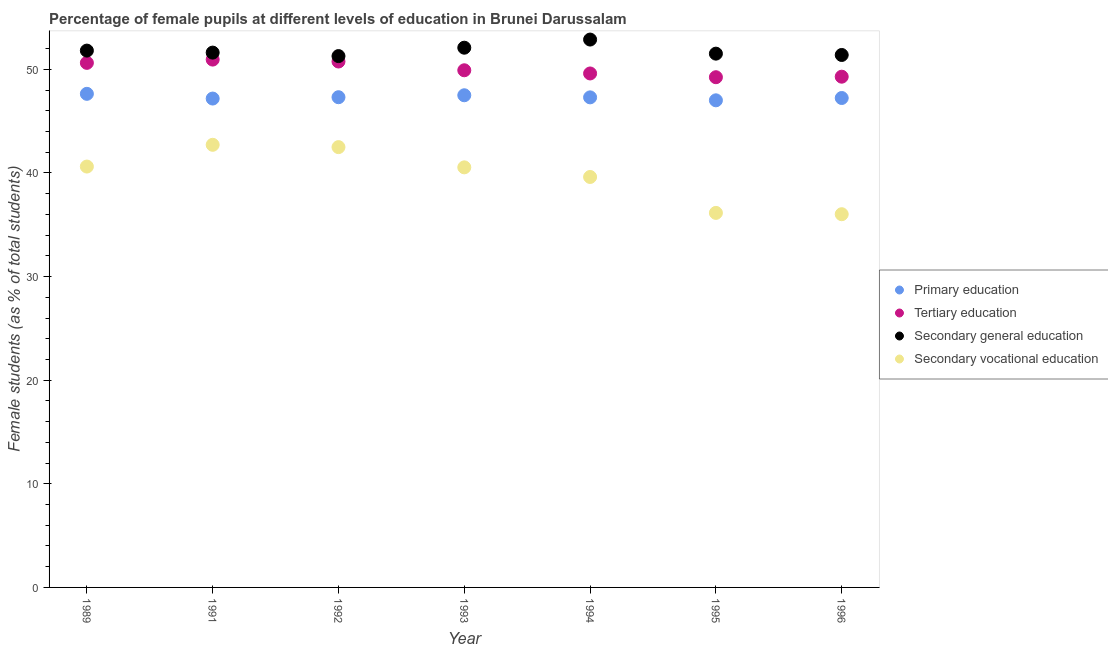What is the percentage of female students in tertiary education in 1993?
Ensure brevity in your answer.  49.91. Across all years, what is the maximum percentage of female students in primary education?
Your answer should be compact. 47.63. Across all years, what is the minimum percentage of female students in tertiary education?
Your answer should be compact. 49.24. In which year was the percentage of female students in secondary vocational education minimum?
Keep it short and to the point. 1996. What is the total percentage of female students in primary education in the graph?
Offer a terse response. 331.15. What is the difference between the percentage of female students in secondary vocational education in 1993 and that in 1996?
Provide a short and direct response. 4.52. What is the difference between the percentage of female students in secondary vocational education in 1993 and the percentage of female students in primary education in 1991?
Ensure brevity in your answer.  -6.64. What is the average percentage of female students in tertiary education per year?
Provide a short and direct response. 50.05. In the year 1989, what is the difference between the percentage of female students in primary education and percentage of female students in secondary education?
Provide a short and direct response. -4.17. In how many years, is the percentage of female students in secondary vocational education greater than 38 %?
Your answer should be compact. 5. What is the ratio of the percentage of female students in secondary education in 1991 to that in 1994?
Keep it short and to the point. 0.98. Is the percentage of female students in secondary education in 1989 less than that in 1992?
Your answer should be very brief. No. What is the difference between the highest and the second highest percentage of female students in secondary vocational education?
Offer a very short reply. 0.22. What is the difference between the highest and the lowest percentage of female students in secondary education?
Ensure brevity in your answer.  1.59. Is the sum of the percentage of female students in secondary vocational education in 1989 and 1991 greater than the maximum percentage of female students in primary education across all years?
Your answer should be compact. Yes. Is it the case that in every year, the sum of the percentage of female students in tertiary education and percentage of female students in secondary education is greater than the sum of percentage of female students in primary education and percentage of female students in secondary vocational education?
Your answer should be very brief. Yes. Is the percentage of female students in secondary education strictly greater than the percentage of female students in tertiary education over the years?
Give a very brief answer. Yes. Where does the legend appear in the graph?
Give a very brief answer. Center right. How are the legend labels stacked?
Offer a terse response. Vertical. What is the title of the graph?
Make the answer very short. Percentage of female pupils at different levels of education in Brunei Darussalam. What is the label or title of the Y-axis?
Offer a very short reply. Female students (as % of total students). What is the Female students (as % of total students) of Primary education in 1989?
Provide a succinct answer. 47.63. What is the Female students (as % of total students) of Tertiary education in 1989?
Ensure brevity in your answer.  50.62. What is the Female students (as % of total students) of Secondary general education in 1989?
Give a very brief answer. 51.81. What is the Female students (as % of total students) of Secondary vocational education in 1989?
Your answer should be compact. 40.62. What is the Female students (as % of total students) of Primary education in 1991?
Your response must be concise. 47.18. What is the Female students (as % of total students) in Tertiary education in 1991?
Your response must be concise. 50.94. What is the Female students (as % of total students) in Secondary general education in 1991?
Your response must be concise. 51.61. What is the Female students (as % of total students) of Secondary vocational education in 1991?
Your response must be concise. 42.72. What is the Female students (as % of total students) of Primary education in 1992?
Keep it short and to the point. 47.31. What is the Female students (as % of total students) of Tertiary education in 1992?
Give a very brief answer. 50.75. What is the Female students (as % of total students) in Secondary general education in 1992?
Provide a succinct answer. 51.28. What is the Female students (as % of total students) of Secondary vocational education in 1992?
Ensure brevity in your answer.  42.49. What is the Female students (as % of total students) in Primary education in 1993?
Your response must be concise. 47.5. What is the Female students (as % of total students) of Tertiary education in 1993?
Provide a succinct answer. 49.91. What is the Female students (as % of total students) of Secondary general education in 1993?
Your answer should be compact. 52.09. What is the Female students (as % of total students) in Secondary vocational education in 1993?
Provide a succinct answer. 40.54. What is the Female students (as % of total students) of Primary education in 1994?
Your answer should be compact. 47.29. What is the Female students (as % of total students) of Tertiary education in 1994?
Offer a very short reply. 49.6. What is the Female students (as % of total students) of Secondary general education in 1994?
Keep it short and to the point. 52.87. What is the Female students (as % of total students) of Secondary vocational education in 1994?
Keep it short and to the point. 39.61. What is the Female students (as % of total students) of Primary education in 1995?
Offer a very short reply. 47.01. What is the Female students (as % of total students) in Tertiary education in 1995?
Give a very brief answer. 49.24. What is the Female students (as % of total students) in Secondary general education in 1995?
Your answer should be compact. 51.51. What is the Female students (as % of total students) in Secondary vocational education in 1995?
Provide a short and direct response. 36.14. What is the Female students (as % of total students) in Primary education in 1996?
Provide a short and direct response. 47.23. What is the Female students (as % of total students) of Tertiary education in 1996?
Your answer should be compact. 49.29. What is the Female students (as % of total students) in Secondary general education in 1996?
Offer a terse response. 51.38. What is the Female students (as % of total students) of Secondary vocational education in 1996?
Keep it short and to the point. 36.02. Across all years, what is the maximum Female students (as % of total students) of Primary education?
Make the answer very short. 47.63. Across all years, what is the maximum Female students (as % of total students) of Tertiary education?
Your answer should be compact. 50.94. Across all years, what is the maximum Female students (as % of total students) in Secondary general education?
Offer a terse response. 52.87. Across all years, what is the maximum Female students (as % of total students) in Secondary vocational education?
Offer a very short reply. 42.72. Across all years, what is the minimum Female students (as % of total students) of Primary education?
Your answer should be compact. 47.01. Across all years, what is the minimum Female students (as % of total students) in Tertiary education?
Your answer should be compact. 49.24. Across all years, what is the minimum Female students (as % of total students) in Secondary general education?
Ensure brevity in your answer.  51.28. Across all years, what is the minimum Female students (as % of total students) in Secondary vocational education?
Offer a terse response. 36.02. What is the total Female students (as % of total students) in Primary education in the graph?
Offer a very short reply. 331.15. What is the total Female students (as % of total students) of Tertiary education in the graph?
Your answer should be very brief. 350.35. What is the total Female students (as % of total students) of Secondary general education in the graph?
Your answer should be compact. 362.55. What is the total Female students (as % of total students) of Secondary vocational education in the graph?
Your answer should be very brief. 278.13. What is the difference between the Female students (as % of total students) in Primary education in 1989 and that in 1991?
Offer a very short reply. 0.46. What is the difference between the Female students (as % of total students) in Tertiary education in 1989 and that in 1991?
Give a very brief answer. -0.32. What is the difference between the Female students (as % of total students) of Secondary general education in 1989 and that in 1991?
Provide a short and direct response. 0.19. What is the difference between the Female students (as % of total students) of Secondary vocational education in 1989 and that in 1991?
Give a very brief answer. -2.1. What is the difference between the Female students (as % of total students) in Primary education in 1989 and that in 1992?
Keep it short and to the point. 0.33. What is the difference between the Female students (as % of total students) of Tertiary education in 1989 and that in 1992?
Provide a short and direct response. -0.13. What is the difference between the Female students (as % of total students) in Secondary general education in 1989 and that in 1992?
Make the answer very short. 0.53. What is the difference between the Female students (as % of total students) of Secondary vocational education in 1989 and that in 1992?
Keep it short and to the point. -1.88. What is the difference between the Female students (as % of total students) of Primary education in 1989 and that in 1993?
Provide a short and direct response. 0.14. What is the difference between the Female students (as % of total students) of Tertiary education in 1989 and that in 1993?
Provide a short and direct response. 0.71. What is the difference between the Female students (as % of total students) of Secondary general education in 1989 and that in 1993?
Make the answer very short. -0.28. What is the difference between the Female students (as % of total students) of Secondary vocational education in 1989 and that in 1993?
Your response must be concise. 0.08. What is the difference between the Female students (as % of total students) in Primary education in 1989 and that in 1994?
Your response must be concise. 0.34. What is the difference between the Female students (as % of total students) of Tertiary education in 1989 and that in 1994?
Offer a terse response. 1.02. What is the difference between the Female students (as % of total students) of Secondary general education in 1989 and that in 1994?
Ensure brevity in your answer.  -1.07. What is the difference between the Female students (as % of total students) in Secondary vocational education in 1989 and that in 1994?
Offer a terse response. 1.01. What is the difference between the Female students (as % of total students) in Primary education in 1989 and that in 1995?
Your response must be concise. 0.63. What is the difference between the Female students (as % of total students) in Tertiary education in 1989 and that in 1995?
Make the answer very short. 1.38. What is the difference between the Female students (as % of total students) of Secondary general education in 1989 and that in 1995?
Provide a short and direct response. 0.29. What is the difference between the Female students (as % of total students) in Secondary vocational education in 1989 and that in 1995?
Your response must be concise. 4.47. What is the difference between the Female students (as % of total students) in Primary education in 1989 and that in 1996?
Your response must be concise. 0.4. What is the difference between the Female students (as % of total students) in Tertiary education in 1989 and that in 1996?
Ensure brevity in your answer.  1.33. What is the difference between the Female students (as % of total students) in Secondary general education in 1989 and that in 1996?
Your answer should be very brief. 0.42. What is the difference between the Female students (as % of total students) in Secondary vocational education in 1989 and that in 1996?
Offer a terse response. 4.6. What is the difference between the Female students (as % of total students) of Primary education in 1991 and that in 1992?
Make the answer very short. -0.13. What is the difference between the Female students (as % of total students) of Tertiary education in 1991 and that in 1992?
Offer a terse response. 0.19. What is the difference between the Female students (as % of total students) of Secondary general education in 1991 and that in 1992?
Ensure brevity in your answer.  0.34. What is the difference between the Female students (as % of total students) of Secondary vocational education in 1991 and that in 1992?
Your answer should be compact. 0.22. What is the difference between the Female students (as % of total students) of Primary education in 1991 and that in 1993?
Offer a very short reply. -0.32. What is the difference between the Female students (as % of total students) of Tertiary education in 1991 and that in 1993?
Ensure brevity in your answer.  1.03. What is the difference between the Female students (as % of total students) in Secondary general education in 1991 and that in 1993?
Ensure brevity in your answer.  -0.47. What is the difference between the Female students (as % of total students) in Secondary vocational education in 1991 and that in 1993?
Your answer should be compact. 2.18. What is the difference between the Female students (as % of total students) of Primary education in 1991 and that in 1994?
Give a very brief answer. -0.12. What is the difference between the Female students (as % of total students) in Tertiary education in 1991 and that in 1994?
Keep it short and to the point. 1.34. What is the difference between the Female students (as % of total students) in Secondary general education in 1991 and that in 1994?
Your answer should be very brief. -1.26. What is the difference between the Female students (as % of total students) of Secondary vocational education in 1991 and that in 1994?
Your response must be concise. 3.1. What is the difference between the Female students (as % of total students) of Primary education in 1991 and that in 1995?
Keep it short and to the point. 0.17. What is the difference between the Female students (as % of total students) of Tertiary education in 1991 and that in 1995?
Your response must be concise. 1.7. What is the difference between the Female students (as % of total students) in Secondary general education in 1991 and that in 1995?
Provide a short and direct response. 0.1. What is the difference between the Female students (as % of total students) of Secondary vocational education in 1991 and that in 1995?
Provide a short and direct response. 6.57. What is the difference between the Female students (as % of total students) of Primary education in 1991 and that in 1996?
Provide a succinct answer. -0.05. What is the difference between the Female students (as % of total students) of Tertiary education in 1991 and that in 1996?
Your response must be concise. 1.65. What is the difference between the Female students (as % of total students) in Secondary general education in 1991 and that in 1996?
Offer a terse response. 0.23. What is the difference between the Female students (as % of total students) in Secondary vocational education in 1991 and that in 1996?
Make the answer very short. 6.7. What is the difference between the Female students (as % of total students) in Primary education in 1992 and that in 1993?
Your answer should be compact. -0.19. What is the difference between the Female students (as % of total students) of Tertiary education in 1992 and that in 1993?
Provide a short and direct response. 0.84. What is the difference between the Female students (as % of total students) in Secondary general education in 1992 and that in 1993?
Give a very brief answer. -0.81. What is the difference between the Female students (as % of total students) in Secondary vocational education in 1992 and that in 1993?
Keep it short and to the point. 1.95. What is the difference between the Female students (as % of total students) in Primary education in 1992 and that in 1994?
Offer a very short reply. 0.01. What is the difference between the Female students (as % of total students) in Tertiary education in 1992 and that in 1994?
Give a very brief answer. 1.15. What is the difference between the Female students (as % of total students) of Secondary general education in 1992 and that in 1994?
Your answer should be very brief. -1.59. What is the difference between the Female students (as % of total students) in Secondary vocational education in 1992 and that in 1994?
Offer a very short reply. 2.88. What is the difference between the Female students (as % of total students) of Primary education in 1992 and that in 1995?
Provide a short and direct response. 0.3. What is the difference between the Female students (as % of total students) in Tertiary education in 1992 and that in 1995?
Offer a terse response. 1.51. What is the difference between the Female students (as % of total students) of Secondary general education in 1992 and that in 1995?
Provide a succinct answer. -0.23. What is the difference between the Female students (as % of total students) in Secondary vocational education in 1992 and that in 1995?
Provide a short and direct response. 6.35. What is the difference between the Female students (as % of total students) in Primary education in 1992 and that in 1996?
Offer a terse response. 0.08. What is the difference between the Female students (as % of total students) in Tertiary education in 1992 and that in 1996?
Provide a succinct answer. 1.46. What is the difference between the Female students (as % of total students) in Secondary general education in 1992 and that in 1996?
Offer a terse response. -0.11. What is the difference between the Female students (as % of total students) of Secondary vocational education in 1992 and that in 1996?
Your response must be concise. 6.48. What is the difference between the Female students (as % of total students) in Primary education in 1993 and that in 1994?
Your answer should be very brief. 0.2. What is the difference between the Female students (as % of total students) in Tertiary education in 1993 and that in 1994?
Provide a short and direct response. 0.31. What is the difference between the Female students (as % of total students) of Secondary general education in 1993 and that in 1994?
Provide a succinct answer. -0.79. What is the difference between the Female students (as % of total students) of Secondary vocational education in 1993 and that in 1994?
Make the answer very short. 0.93. What is the difference between the Female students (as % of total students) of Primary education in 1993 and that in 1995?
Keep it short and to the point. 0.49. What is the difference between the Female students (as % of total students) in Tertiary education in 1993 and that in 1995?
Your answer should be very brief. 0.67. What is the difference between the Female students (as % of total students) in Secondary general education in 1993 and that in 1995?
Offer a very short reply. 0.57. What is the difference between the Female students (as % of total students) in Secondary vocational education in 1993 and that in 1995?
Give a very brief answer. 4.39. What is the difference between the Female students (as % of total students) in Primary education in 1993 and that in 1996?
Provide a short and direct response. 0.26. What is the difference between the Female students (as % of total students) in Tertiary education in 1993 and that in 1996?
Provide a succinct answer. 0.62. What is the difference between the Female students (as % of total students) of Secondary general education in 1993 and that in 1996?
Offer a very short reply. 0.7. What is the difference between the Female students (as % of total students) of Secondary vocational education in 1993 and that in 1996?
Offer a very short reply. 4.52. What is the difference between the Female students (as % of total students) in Primary education in 1994 and that in 1995?
Your answer should be very brief. 0.29. What is the difference between the Female students (as % of total students) in Tertiary education in 1994 and that in 1995?
Your answer should be very brief. 0.36. What is the difference between the Female students (as % of total students) in Secondary general education in 1994 and that in 1995?
Keep it short and to the point. 1.36. What is the difference between the Female students (as % of total students) of Secondary vocational education in 1994 and that in 1995?
Your answer should be compact. 3.47. What is the difference between the Female students (as % of total students) of Primary education in 1994 and that in 1996?
Your response must be concise. 0.06. What is the difference between the Female students (as % of total students) in Tertiary education in 1994 and that in 1996?
Your response must be concise. 0.31. What is the difference between the Female students (as % of total students) of Secondary general education in 1994 and that in 1996?
Offer a very short reply. 1.49. What is the difference between the Female students (as % of total students) of Secondary vocational education in 1994 and that in 1996?
Offer a very short reply. 3.59. What is the difference between the Female students (as % of total students) in Primary education in 1995 and that in 1996?
Your answer should be very brief. -0.22. What is the difference between the Female students (as % of total students) of Tertiary education in 1995 and that in 1996?
Your answer should be very brief. -0.05. What is the difference between the Female students (as % of total students) of Secondary general education in 1995 and that in 1996?
Your answer should be compact. 0.13. What is the difference between the Female students (as % of total students) in Secondary vocational education in 1995 and that in 1996?
Offer a terse response. 0.13. What is the difference between the Female students (as % of total students) of Primary education in 1989 and the Female students (as % of total students) of Tertiary education in 1991?
Your answer should be very brief. -3.3. What is the difference between the Female students (as % of total students) in Primary education in 1989 and the Female students (as % of total students) in Secondary general education in 1991?
Your answer should be compact. -3.98. What is the difference between the Female students (as % of total students) of Primary education in 1989 and the Female students (as % of total students) of Secondary vocational education in 1991?
Give a very brief answer. 4.92. What is the difference between the Female students (as % of total students) in Tertiary education in 1989 and the Female students (as % of total students) in Secondary general education in 1991?
Keep it short and to the point. -0.99. What is the difference between the Female students (as % of total students) in Tertiary education in 1989 and the Female students (as % of total students) in Secondary vocational education in 1991?
Give a very brief answer. 7.91. What is the difference between the Female students (as % of total students) of Secondary general education in 1989 and the Female students (as % of total students) of Secondary vocational education in 1991?
Keep it short and to the point. 9.09. What is the difference between the Female students (as % of total students) in Primary education in 1989 and the Female students (as % of total students) in Tertiary education in 1992?
Provide a short and direct response. -3.12. What is the difference between the Female students (as % of total students) in Primary education in 1989 and the Female students (as % of total students) in Secondary general education in 1992?
Give a very brief answer. -3.64. What is the difference between the Female students (as % of total students) in Primary education in 1989 and the Female students (as % of total students) in Secondary vocational education in 1992?
Offer a very short reply. 5.14. What is the difference between the Female students (as % of total students) in Tertiary education in 1989 and the Female students (as % of total students) in Secondary general education in 1992?
Your answer should be very brief. -0.66. What is the difference between the Female students (as % of total students) of Tertiary education in 1989 and the Female students (as % of total students) of Secondary vocational education in 1992?
Provide a short and direct response. 8.13. What is the difference between the Female students (as % of total students) of Secondary general education in 1989 and the Female students (as % of total students) of Secondary vocational education in 1992?
Provide a short and direct response. 9.31. What is the difference between the Female students (as % of total students) of Primary education in 1989 and the Female students (as % of total students) of Tertiary education in 1993?
Your answer should be very brief. -2.27. What is the difference between the Female students (as % of total students) in Primary education in 1989 and the Female students (as % of total students) in Secondary general education in 1993?
Offer a terse response. -4.45. What is the difference between the Female students (as % of total students) of Primary education in 1989 and the Female students (as % of total students) of Secondary vocational education in 1993?
Your response must be concise. 7.1. What is the difference between the Female students (as % of total students) in Tertiary education in 1989 and the Female students (as % of total students) in Secondary general education in 1993?
Make the answer very short. -1.46. What is the difference between the Female students (as % of total students) of Tertiary education in 1989 and the Female students (as % of total students) of Secondary vocational education in 1993?
Your answer should be very brief. 10.08. What is the difference between the Female students (as % of total students) of Secondary general education in 1989 and the Female students (as % of total students) of Secondary vocational education in 1993?
Provide a short and direct response. 11.27. What is the difference between the Female students (as % of total students) of Primary education in 1989 and the Female students (as % of total students) of Tertiary education in 1994?
Make the answer very short. -1.97. What is the difference between the Female students (as % of total students) in Primary education in 1989 and the Female students (as % of total students) in Secondary general education in 1994?
Your answer should be very brief. -5.24. What is the difference between the Female students (as % of total students) in Primary education in 1989 and the Female students (as % of total students) in Secondary vocational education in 1994?
Provide a short and direct response. 8.02. What is the difference between the Female students (as % of total students) in Tertiary education in 1989 and the Female students (as % of total students) in Secondary general education in 1994?
Ensure brevity in your answer.  -2.25. What is the difference between the Female students (as % of total students) in Tertiary education in 1989 and the Female students (as % of total students) in Secondary vocational education in 1994?
Give a very brief answer. 11.01. What is the difference between the Female students (as % of total students) in Secondary general education in 1989 and the Female students (as % of total students) in Secondary vocational education in 1994?
Keep it short and to the point. 12.2. What is the difference between the Female students (as % of total students) of Primary education in 1989 and the Female students (as % of total students) of Tertiary education in 1995?
Make the answer very short. -1.6. What is the difference between the Female students (as % of total students) in Primary education in 1989 and the Female students (as % of total students) in Secondary general education in 1995?
Offer a terse response. -3.88. What is the difference between the Female students (as % of total students) of Primary education in 1989 and the Female students (as % of total students) of Secondary vocational education in 1995?
Make the answer very short. 11.49. What is the difference between the Female students (as % of total students) in Tertiary education in 1989 and the Female students (as % of total students) in Secondary general education in 1995?
Provide a short and direct response. -0.89. What is the difference between the Female students (as % of total students) in Tertiary education in 1989 and the Female students (as % of total students) in Secondary vocational education in 1995?
Provide a succinct answer. 14.48. What is the difference between the Female students (as % of total students) in Secondary general education in 1989 and the Female students (as % of total students) in Secondary vocational education in 1995?
Your answer should be compact. 15.66. What is the difference between the Female students (as % of total students) of Primary education in 1989 and the Female students (as % of total students) of Tertiary education in 1996?
Ensure brevity in your answer.  -1.65. What is the difference between the Female students (as % of total students) of Primary education in 1989 and the Female students (as % of total students) of Secondary general education in 1996?
Make the answer very short. -3.75. What is the difference between the Female students (as % of total students) in Primary education in 1989 and the Female students (as % of total students) in Secondary vocational education in 1996?
Provide a short and direct response. 11.62. What is the difference between the Female students (as % of total students) in Tertiary education in 1989 and the Female students (as % of total students) in Secondary general education in 1996?
Give a very brief answer. -0.76. What is the difference between the Female students (as % of total students) of Tertiary education in 1989 and the Female students (as % of total students) of Secondary vocational education in 1996?
Provide a short and direct response. 14.61. What is the difference between the Female students (as % of total students) of Secondary general education in 1989 and the Female students (as % of total students) of Secondary vocational education in 1996?
Offer a very short reply. 15.79. What is the difference between the Female students (as % of total students) of Primary education in 1991 and the Female students (as % of total students) of Tertiary education in 1992?
Ensure brevity in your answer.  -3.57. What is the difference between the Female students (as % of total students) of Primary education in 1991 and the Female students (as % of total students) of Secondary general education in 1992?
Provide a short and direct response. -4.1. What is the difference between the Female students (as % of total students) in Primary education in 1991 and the Female students (as % of total students) in Secondary vocational education in 1992?
Your answer should be compact. 4.69. What is the difference between the Female students (as % of total students) of Tertiary education in 1991 and the Female students (as % of total students) of Secondary general education in 1992?
Make the answer very short. -0.34. What is the difference between the Female students (as % of total students) in Tertiary education in 1991 and the Female students (as % of total students) in Secondary vocational education in 1992?
Keep it short and to the point. 8.45. What is the difference between the Female students (as % of total students) of Secondary general education in 1991 and the Female students (as % of total students) of Secondary vocational education in 1992?
Keep it short and to the point. 9.12. What is the difference between the Female students (as % of total students) in Primary education in 1991 and the Female students (as % of total students) in Tertiary education in 1993?
Keep it short and to the point. -2.73. What is the difference between the Female students (as % of total students) in Primary education in 1991 and the Female students (as % of total students) in Secondary general education in 1993?
Your answer should be compact. -4.91. What is the difference between the Female students (as % of total students) in Primary education in 1991 and the Female students (as % of total students) in Secondary vocational education in 1993?
Your response must be concise. 6.64. What is the difference between the Female students (as % of total students) in Tertiary education in 1991 and the Female students (as % of total students) in Secondary general education in 1993?
Give a very brief answer. -1.15. What is the difference between the Female students (as % of total students) in Tertiary education in 1991 and the Female students (as % of total students) in Secondary vocational education in 1993?
Your answer should be very brief. 10.4. What is the difference between the Female students (as % of total students) in Secondary general education in 1991 and the Female students (as % of total students) in Secondary vocational education in 1993?
Provide a short and direct response. 11.07. What is the difference between the Female students (as % of total students) in Primary education in 1991 and the Female students (as % of total students) in Tertiary education in 1994?
Provide a short and direct response. -2.42. What is the difference between the Female students (as % of total students) of Primary education in 1991 and the Female students (as % of total students) of Secondary general education in 1994?
Provide a succinct answer. -5.69. What is the difference between the Female students (as % of total students) of Primary education in 1991 and the Female students (as % of total students) of Secondary vocational education in 1994?
Provide a short and direct response. 7.57. What is the difference between the Female students (as % of total students) of Tertiary education in 1991 and the Female students (as % of total students) of Secondary general education in 1994?
Provide a succinct answer. -1.93. What is the difference between the Female students (as % of total students) in Tertiary education in 1991 and the Female students (as % of total students) in Secondary vocational education in 1994?
Your answer should be compact. 11.33. What is the difference between the Female students (as % of total students) of Secondary general education in 1991 and the Female students (as % of total students) of Secondary vocational education in 1994?
Provide a short and direct response. 12. What is the difference between the Female students (as % of total students) of Primary education in 1991 and the Female students (as % of total students) of Tertiary education in 1995?
Your response must be concise. -2.06. What is the difference between the Female students (as % of total students) in Primary education in 1991 and the Female students (as % of total students) in Secondary general education in 1995?
Your answer should be compact. -4.33. What is the difference between the Female students (as % of total students) of Primary education in 1991 and the Female students (as % of total students) of Secondary vocational education in 1995?
Give a very brief answer. 11.03. What is the difference between the Female students (as % of total students) in Tertiary education in 1991 and the Female students (as % of total students) in Secondary general education in 1995?
Your answer should be very brief. -0.57. What is the difference between the Female students (as % of total students) in Tertiary education in 1991 and the Female students (as % of total students) in Secondary vocational education in 1995?
Offer a terse response. 14.79. What is the difference between the Female students (as % of total students) of Secondary general education in 1991 and the Female students (as % of total students) of Secondary vocational education in 1995?
Offer a terse response. 15.47. What is the difference between the Female students (as % of total students) in Primary education in 1991 and the Female students (as % of total students) in Tertiary education in 1996?
Your response must be concise. -2.11. What is the difference between the Female students (as % of total students) in Primary education in 1991 and the Female students (as % of total students) in Secondary general education in 1996?
Make the answer very short. -4.21. What is the difference between the Female students (as % of total students) in Primary education in 1991 and the Female students (as % of total students) in Secondary vocational education in 1996?
Give a very brief answer. 11.16. What is the difference between the Female students (as % of total students) in Tertiary education in 1991 and the Female students (as % of total students) in Secondary general education in 1996?
Offer a terse response. -0.45. What is the difference between the Female students (as % of total students) of Tertiary education in 1991 and the Female students (as % of total students) of Secondary vocational education in 1996?
Your answer should be compact. 14.92. What is the difference between the Female students (as % of total students) of Secondary general education in 1991 and the Female students (as % of total students) of Secondary vocational education in 1996?
Offer a terse response. 15.6. What is the difference between the Female students (as % of total students) of Primary education in 1992 and the Female students (as % of total students) of Tertiary education in 1993?
Ensure brevity in your answer.  -2.6. What is the difference between the Female students (as % of total students) in Primary education in 1992 and the Female students (as % of total students) in Secondary general education in 1993?
Your answer should be very brief. -4.78. What is the difference between the Female students (as % of total students) in Primary education in 1992 and the Female students (as % of total students) in Secondary vocational education in 1993?
Offer a very short reply. 6.77. What is the difference between the Female students (as % of total students) in Tertiary education in 1992 and the Female students (as % of total students) in Secondary general education in 1993?
Your response must be concise. -1.33. What is the difference between the Female students (as % of total students) in Tertiary education in 1992 and the Female students (as % of total students) in Secondary vocational education in 1993?
Provide a succinct answer. 10.21. What is the difference between the Female students (as % of total students) of Secondary general education in 1992 and the Female students (as % of total students) of Secondary vocational education in 1993?
Provide a succinct answer. 10.74. What is the difference between the Female students (as % of total students) of Primary education in 1992 and the Female students (as % of total students) of Tertiary education in 1994?
Offer a terse response. -2.29. What is the difference between the Female students (as % of total students) of Primary education in 1992 and the Female students (as % of total students) of Secondary general education in 1994?
Your response must be concise. -5.56. What is the difference between the Female students (as % of total students) of Primary education in 1992 and the Female students (as % of total students) of Secondary vocational education in 1994?
Offer a terse response. 7.7. What is the difference between the Female students (as % of total students) of Tertiary education in 1992 and the Female students (as % of total students) of Secondary general education in 1994?
Give a very brief answer. -2.12. What is the difference between the Female students (as % of total students) in Tertiary education in 1992 and the Female students (as % of total students) in Secondary vocational education in 1994?
Make the answer very short. 11.14. What is the difference between the Female students (as % of total students) of Secondary general education in 1992 and the Female students (as % of total students) of Secondary vocational education in 1994?
Make the answer very short. 11.67. What is the difference between the Female students (as % of total students) of Primary education in 1992 and the Female students (as % of total students) of Tertiary education in 1995?
Provide a short and direct response. -1.93. What is the difference between the Female students (as % of total students) of Primary education in 1992 and the Female students (as % of total students) of Secondary general education in 1995?
Provide a succinct answer. -4.2. What is the difference between the Female students (as % of total students) of Primary education in 1992 and the Female students (as % of total students) of Secondary vocational education in 1995?
Make the answer very short. 11.16. What is the difference between the Female students (as % of total students) of Tertiary education in 1992 and the Female students (as % of total students) of Secondary general education in 1995?
Ensure brevity in your answer.  -0.76. What is the difference between the Female students (as % of total students) of Tertiary education in 1992 and the Female students (as % of total students) of Secondary vocational education in 1995?
Ensure brevity in your answer.  14.61. What is the difference between the Female students (as % of total students) of Secondary general education in 1992 and the Female students (as % of total students) of Secondary vocational education in 1995?
Your response must be concise. 15.13. What is the difference between the Female students (as % of total students) in Primary education in 1992 and the Female students (as % of total students) in Tertiary education in 1996?
Offer a terse response. -1.98. What is the difference between the Female students (as % of total students) of Primary education in 1992 and the Female students (as % of total students) of Secondary general education in 1996?
Ensure brevity in your answer.  -4.08. What is the difference between the Female students (as % of total students) in Primary education in 1992 and the Female students (as % of total students) in Secondary vocational education in 1996?
Keep it short and to the point. 11.29. What is the difference between the Female students (as % of total students) of Tertiary education in 1992 and the Female students (as % of total students) of Secondary general education in 1996?
Keep it short and to the point. -0.63. What is the difference between the Female students (as % of total students) of Tertiary education in 1992 and the Female students (as % of total students) of Secondary vocational education in 1996?
Ensure brevity in your answer.  14.74. What is the difference between the Female students (as % of total students) of Secondary general education in 1992 and the Female students (as % of total students) of Secondary vocational education in 1996?
Provide a succinct answer. 15.26. What is the difference between the Female students (as % of total students) of Primary education in 1993 and the Female students (as % of total students) of Tertiary education in 1994?
Your answer should be compact. -2.1. What is the difference between the Female students (as % of total students) of Primary education in 1993 and the Female students (as % of total students) of Secondary general education in 1994?
Keep it short and to the point. -5.38. What is the difference between the Female students (as % of total students) of Primary education in 1993 and the Female students (as % of total students) of Secondary vocational education in 1994?
Your response must be concise. 7.89. What is the difference between the Female students (as % of total students) in Tertiary education in 1993 and the Female students (as % of total students) in Secondary general education in 1994?
Your answer should be very brief. -2.96. What is the difference between the Female students (as % of total students) in Tertiary education in 1993 and the Female students (as % of total students) in Secondary vocational education in 1994?
Offer a very short reply. 10.3. What is the difference between the Female students (as % of total students) of Secondary general education in 1993 and the Female students (as % of total students) of Secondary vocational education in 1994?
Keep it short and to the point. 12.48. What is the difference between the Female students (as % of total students) of Primary education in 1993 and the Female students (as % of total students) of Tertiary education in 1995?
Your answer should be compact. -1.74. What is the difference between the Female students (as % of total students) of Primary education in 1993 and the Female students (as % of total students) of Secondary general education in 1995?
Your answer should be very brief. -4.02. What is the difference between the Female students (as % of total students) in Primary education in 1993 and the Female students (as % of total students) in Secondary vocational education in 1995?
Your response must be concise. 11.35. What is the difference between the Female students (as % of total students) of Tertiary education in 1993 and the Female students (as % of total students) of Secondary general education in 1995?
Your response must be concise. -1.6. What is the difference between the Female students (as % of total students) of Tertiary education in 1993 and the Female students (as % of total students) of Secondary vocational education in 1995?
Provide a succinct answer. 13.76. What is the difference between the Female students (as % of total students) of Secondary general education in 1993 and the Female students (as % of total students) of Secondary vocational education in 1995?
Your answer should be very brief. 15.94. What is the difference between the Female students (as % of total students) of Primary education in 1993 and the Female students (as % of total students) of Tertiary education in 1996?
Provide a succinct answer. -1.79. What is the difference between the Female students (as % of total students) in Primary education in 1993 and the Female students (as % of total students) in Secondary general education in 1996?
Provide a short and direct response. -3.89. What is the difference between the Female students (as % of total students) of Primary education in 1993 and the Female students (as % of total students) of Secondary vocational education in 1996?
Make the answer very short. 11.48. What is the difference between the Female students (as % of total students) in Tertiary education in 1993 and the Female students (as % of total students) in Secondary general education in 1996?
Make the answer very short. -1.48. What is the difference between the Female students (as % of total students) in Tertiary education in 1993 and the Female students (as % of total students) in Secondary vocational education in 1996?
Give a very brief answer. 13.89. What is the difference between the Female students (as % of total students) of Secondary general education in 1993 and the Female students (as % of total students) of Secondary vocational education in 1996?
Ensure brevity in your answer.  16.07. What is the difference between the Female students (as % of total students) in Primary education in 1994 and the Female students (as % of total students) in Tertiary education in 1995?
Provide a succinct answer. -1.94. What is the difference between the Female students (as % of total students) of Primary education in 1994 and the Female students (as % of total students) of Secondary general education in 1995?
Keep it short and to the point. -4.22. What is the difference between the Female students (as % of total students) in Primary education in 1994 and the Female students (as % of total students) in Secondary vocational education in 1995?
Offer a very short reply. 11.15. What is the difference between the Female students (as % of total students) in Tertiary education in 1994 and the Female students (as % of total students) in Secondary general education in 1995?
Offer a terse response. -1.91. What is the difference between the Female students (as % of total students) of Tertiary education in 1994 and the Female students (as % of total students) of Secondary vocational education in 1995?
Offer a terse response. 13.46. What is the difference between the Female students (as % of total students) of Secondary general education in 1994 and the Female students (as % of total students) of Secondary vocational education in 1995?
Provide a short and direct response. 16.73. What is the difference between the Female students (as % of total students) in Primary education in 1994 and the Female students (as % of total students) in Tertiary education in 1996?
Offer a terse response. -1.99. What is the difference between the Female students (as % of total students) in Primary education in 1994 and the Female students (as % of total students) in Secondary general education in 1996?
Provide a succinct answer. -4.09. What is the difference between the Female students (as % of total students) in Primary education in 1994 and the Female students (as % of total students) in Secondary vocational education in 1996?
Provide a succinct answer. 11.28. What is the difference between the Female students (as % of total students) in Tertiary education in 1994 and the Female students (as % of total students) in Secondary general education in 1996?
Ensure brevity in your answer.  -1.78. What is the difference between the Female students (as % of total students) of Tertiary education in 1994 and the Female students (as % of total students) of Secondary vocational education in 1996?
Keep it short and to the point. 13.58. What is the difference between the Female students (as % of total students) of Secondary general education in 1994 and the Female students (as % of total students) of Secondary vocational education in 1996?
Your answer should be very brief. 16.86. What is the difference between the Female students (as % of total students) in Primary education in 1995 and the Female students (as % of total students) in Tertiary education in 1996?
Keep it short and to the point. -2.28. What is the difference between the Female students (as % of total students) of Primary education in 1995 and the Female students (as % of total students) of Secondary general education in 1996?
Keep it short and to the point. -4.38. What is the difference between the Female students (as % of total students) in Primary education in 1995 and the Female students (as % of total students) in Secondary vocational education in 1996?
Your response must be concise. 10.99. What is the difference between the Female students (as % of total students) in Tertiary education in 1995 and the Female students (as % of total students) in Secondary general education in 1996?
Provide a succinct answer. -2.15. What is the difference between the Female students (as % of total students) in Tertiary education in 1995 and the Female students (as % of total students) in Secondary vocational education in 1996?
Keep it short and to the point. 13.22. What is the difference between the Female students (as % of total students) in Secondary general education in 1995 and the Female students (as % of total students) in Secondary vocational education in 1996?
Provide a short and direct response. 15.5. What is the average Female students (as % of total students) of Primary education per year?
Make the answer very short. 47.31. What is the average Female students (as % of total students) of Tertiary education per year?
Make the answer very short. 50.05. What is the average Female students (as % of total students) in Secondary general education per year?
Provide a short and direct response. 51.79. What is the average Female students (as % of total students) in Secondary vocational education per year?
Ensure brevity in your answer.  39.73. In the year 1989, what is the difference between the Female students (as % of total students) in Primary education and Female students (as % of total students) in Tertiary education?
Offer a very short reply. -2.99. In the year 1989, what is the difference between the Female students (as % of total students) of Primary education and Female students (as % of total students) of Secondary general education?
Offer a very short reply. -4.17. In the year 1989, what is the difference between the Female students (as % of total students) in Primary education and Female students (as % of total students) in Secondary vocational education?
Offer a terse response. 7.02. In the year 1989, what is the difference between the Female students (as % of total students) in Tertiary education and Female students (as % of total students) in Secondary general education?
Provide a succinct answer. -1.18. In the year 1989, what is the difference between the Female students (as % of total students) in Tertiary education and Female students (as % of total students) in Secondary vocational education?
Make the answer very short. 10.01. In the year 1989, what is the difference between the Female students (as % of total students) of Secondary general education and Female students (as % of total students) of Secondary vocational education?
Give a very brief answer. 11.19. In the year 1991, what is the difference between the Female students (as % of total students) in Primary education and Female students (as % of total students) in Tertiary education?
Your answer should be compact. -3.76. In the year 1991, what is the difference between the Female students (as % of total students) of Primary education and Female students (as % of total students) of Secondary general education?
Offer a very short reply. -4.43. In the year 1991, what is the difference between the Female students (as % of total students) of Primary education and Female students (as % of total students) of Secondary vocational education?
Your answer should be compact. 4.46. In the year 1991, what is the difference between the Female students (as % of total students) of Tertiary education and Female students (as % of total students) of Secondary general education?
Your answer should be compact. -0.67. In the year 1991, what is the difference between the Female students (as % of total students) in Tertiary education and Female students (as % of total students) in Secondary vocational education?
Your answer should be very brief. 8.22. In the year 1991, what is the difference between the Female students (as % of total students) of Secondary general education and Female students (as % of total students) of Secondary vocational education?
Your answer should be compact. 8.9. In the year 1992, what is the difference between the Female students (as % of total students) of Primary education and Female students (as % of total students) of Tertiary education?
Give a very brief answer. -3.44. In the year 1992, what is the difference between the Female students (as % of total students) of Primary education and Female students (as % of total students) of Secondary general education?
Your response must be concise. -3.97. In the year 1992, what is the difference between the Female students (as % of total students) of Primary education and Female students (as % of total students) of Secondary vocational education?
Your answer should be very brief. 4.82. In the year 1992, what is the difference between the Female students (as % of total students) in Tertiary education and Female students (as % of total students) in Secondary general education?
Ensure brevity in your answer.  -0.52. In the year 1992, what is the difference between the Female students (as % of total students) of Tertiary education and Female students (as % of total students) of Secondary vocational education?
Give a very brief answer. 8.26. In the year 1992, what is the difference between the Female students (as % of total students) of Secondary general education and Female students (as % of total students) of Secondary vocational education?
Your response must be concise. 8.79. In the year 1993, what is the difference between the Female students (as % of total students) of Primary education and Female students (as % of total students) of Tertiary education?
Your response must be concise. -2.41. In the year 1993, what is the difference between the Female students (as % of total students) of Primary education and Female students (as % of total students) of Secondary general education?
Your answer should be compact. -4.59. In the year 1993, what is the difference between the Female students (as % of total students) of Primary education and Female students (as % of total students) of Secondary vocational education?
Your answer should be compact. 6.96. In the year 1993, what is the difference between the Female students (as % of total students) of Tertiary education and Female students (as % of total students) of Secondary general education?
Offer a terse response. -2.18. In the year 1993, what is the difference between the Female students (as % of total students) in Tertiary education and Female students (as % of total students) in Secondary vocational education?
Ensure brevity in your answer.  9.37. In the year 1993, what is the difference between the Female students (as % of total students) of Secondary general education and Female students (as % of total students) of Secondary vocational education?
Keep it short and to the point. 11.55. In the year 1994, what is the difference between the Female students (as % of total students) of Primary education and Female students (as % of total students) of Tertiary education?
Provide a short and direct response. -2.31. In the year 1994, what is the difference between the Female students (as % of total students) in Primary education and Female students (as % of total students) in Secondary general education?
Your answer should be compact. -5.58. In the year 1994, what is the difference between the Female students (as % of total students) in Primary education and Female students (as % of total students) in Secondary vocational education?
Make the answer very short. 7.68. In the year 1994, what is the difference between the Female students (as % of total students) of Tertiary education and Female students (as % of total students) of Secondary general education?
Keep it short and to the point. -3.27. In the year 1994, what is the difference between the Female students (as % of total students) in Tertiary education and Female students (as % of total students) in Secondary vocational education?
Offer a terse response. 9.99. In the year 1994, what is the difference between the Female students (as % of total students) in Secondary general education and Female students (as % of total students) in Secondary vocational education?
Ensure brevity in your answer.  13.26. In the year 1995, what is the difference between the Female students (as % of total students) of Primary education and Female students (as % of total students) of Tertiary education?
Make the answer very short. -2.23. In the year 1995, what is the difference between the Female students (as % of total students) in Primary education and Female students (as % of total students) in Secondary general education?
Provide a succinct answer. -4.5. In the year 1995, what is the difference between the Female students (as % of total students) in Primary education and Female students (as % of total students) in Secondary vocational education?
Provide a short and direct response. 10.86. In the year 1995, what is the difference between the Female students (as % of total students) in Tertiary education and Female students (as % of total students) in Secondary general education?
Your answer should be very brief. -2.27. In the year 1995, what is the difference between the Female students (as % of total students) in Tertiary education and Female students (as % of total students) in Secondary vocational education?
Ensure brevity in your answer.  13.09. In the year 1995, what is the difference between the Female students (as % of total students) in Secondary general education and Female students (as % of total students) in Secondary vocational education?
Give a very brief answer. 15.37. In the year 1996, what is the difference between the Female students (as % of total students) in Primary education and Female students (as % of total students) in Tertiary education?
Make the answer very short. -2.06. In the year 1996, what is the difference between the Female students (as % of total students) in Primary education and Female students (as % of total students) in Secondary general education?
Keep it short and to the point. -4.15. In the year 1996, what is the difference between the Female students (as % of total students) in Primary education and Female students (as % of total students) in Secondary vocational education?
Provide a short and direct response. 11.21. In the year 1996, what is the difference between the Female students (as % of total students) of Tertiary education and Female students (as % of total students) of Secondary general education?
Your answer should be very brief. -2.1. In the year 1996, what is the difference between the Female students (as % of total students) in Tertiary education and Female students (as % of total students) in Secondary vocational education?
Provide a short and direct response. 13.27. In the year 1996, what is the difference between the Female students (as % of total students) of Secondary general education and Female students (as % of total students) of Secondary vocational education?
Ensure brevity in your answer.  15.37. What is the ratio of the Female students (as % of total students) of Primary education in 1989 to that in 1991?
Keep it short and to the point. 1.01. What is the ratio of the Female students (as % of total students) of Secondary vocational education in 1989 to that in 1991?
Your response must be concise. 0.95. What is the ratio of the Female students (as % of total students) in Primary education in 1989 to that in 1992?
Offer a very short reply. 1.01. What is the ratio of the Female students (as % of total students) in Secondary general education in 1989 to that in 1992?
Ensure brevity in your answer.  1.01. What is the ratio of the Female students (as % of total students) in Secondary vocational education in 1989 to that in 1992?
Offer a very short reply. 0.96. What is the ratio of the Female students (as % of total students) in Primary education in 1989 to that in 1993?
Provide a short and direct response. 1. What is the ratio of the Female students (as % of total students) in Tertiary education in 1989 to that in 1993?
Make the answer very short. 1.01. What is the ratio of the Female students (as % of total students) in Secondary general education in 1989 to that in 1993?
Your answer should be compact. 0.99. What is the ratio of the Female students (as % of total students) in Tertiary education in 1989 to that in 1994?
Provide a short and direct response. 1.02. What is the ratio of the Female students (as % of total students) of Secondary general education in 1989 to that in 1994?
Ensure brevity in your answer.  0.98. What is the ratio of the Female students (as % of total students) in Secondary vocational education in 1989 to that in 1994?
Ensure brevity in your answer.  1.03. What is the ratio of the Female students (as % of total students) of Primary education in 1989 to that in 1995?
Keep it short and to the point. 1.01. What is the ratio of the Female students (as % of total students) of Tertiary education in 1989 to that in 1995?
Your answer should be compact. 1.03. What is the ratio of the Female students (as % of total students) of Secondary general education in 1989 to that in 1995?
Your answer should be very brief. 1.01. What is the ratio of the Female students (as % of total students) in Secondary vocational education in 1989 to that in 1995?
Give a very brief answer. 1.12. What is the ratio of the Female students (as % of total students) in Primary education in 1989 to that in 1996?
Give a very brief answer. 1.01. What is the ratio of the Female students (as % of total students) in Tertiary education in 1989 to that in 1996?
Your response must be concise. 1.03. What is the ratio of the Female students (as % of total students) in Secondary general education in 1989 to that in 1996?
Offer a terse response. 1.01. What is the ratio of the Female students (as % of total students) of Secondary vocational education in 1989 to that in 1996?
Your response must be concise. 1.13. What is the ratio of the Female students (as % of total students) in Secondary general education in 1991 to that in 1992?
Offer a terse response. 1.01. What is the ratio of the Female students (as % of total students) in Primary education in 1991 to that in 1993?
Keep it short and to the point. 0.99. What is the ratio of the Female students (as % of total students) in Tertiary education in 1991 to that in 1993?
Your answer should be compact. 1.02. What is the ratio of the Female students (as % of total students) of Secondary general education in 1991 to that in 1993?
Offer a very short reply. 0.99. What is the ratio of the Female students (as % of total students) of Secondary vocational education in 1991 to that in 1993?
Offer a very short reply. 1.05. What is the ratio of the Female students (as % of total students) of Primary education in 1991 to that in 1994?
Offer a very short reply. 1. What is the ratio of the Female students (as % of total students) of Secondary general education in 1991 to that in 1994?
Provide a succinct answer. 0.98. What is the ratio of the Female students (as % of total students) in Secondary vocational education in 1991 to that in 1994?
Make the answer very short. 1.08. What is the ratio of the Female students (as % of total students) in Tertiary education in 1991 to that in 1995?
Provide a succinct answer. 1.03. What is the ratio of the Female students (as % of total students) in Secondary vocational education in 1991 to that in 1995?
Ensure brevity in your answer.  1.18. What is the ratio of the Female students (as % of total students) in Tertiary education in 1991 to that in 1996?
Keep it short and to the point. 1.03. What is the ratio of the Female students (as % of total students) of Secondary vocational education in 1991 to that in 1996?
Keep it short and to the point. 1.19. What is the ratio of the Female students (as % of total students) in Primary education in 1992 to that in 1993?
Provide a short and direct response. 1. What is the ratio of the Female students (as % of total students) in Tertiary education in 1992 to that in 1993?
Provide a short and direct response. 1.02. What is the ratio of the Female students (as % of total students) in Secondary general education in 1992 to that in 1993?
Offer a very short reply. 0.98. What is the ratio of the Female students (as % of total students) of Secondary vocational education in 1992 to that in 1993?
Offer a terse response. 1.05. What is the ratio of the Female students (as % of total students) in Tertiary education in 1992 to that in 1994?
Keep it short and to the point. 1.02. What is the ratio of the Female students (as % of total students) of Secondary general education in 1992 to that in 1994?
Your answer should be compact. 0.97. What is the ratio of the Female students (as % of total students) in Secondary vocational education in 1992 to that in 1994?
Offer a terse response. 1.07. What is the ratio of the Female students (as % of total students) in Primary education in 1992 to that in 1995?
Provide a succinct answer. 1.01. What is the ratio of the Female students (as % of total students) in Tertiary education in 1992 to that in 1995?
Offer a terse response. 1.03. What is the ratio of the Female students (as % of total students) in Secondary vocational education in 1992 to that in 1995?
Offer a very short reply. 1.18. What is the ratio of the Female students (as % of total students) in Tertiary education in 1992 to that in 1996?
Provide a short and direct response. 1.03. What is the ratio of the Female students (as % of total students) of Secondary general education in 1992 to that in 1996?
Ensure brevity in your answer.  1. What is the ratio of the Female students (as % of total students) in Secondary vocational education in 1992 to that in 1996?
Provide a succinct answer. 1.18. What is the ratio of the Female students (as % of total students) in Tertiary education in 1993 to that in 1994?
Your response must be concise. 1.01. What is the ratio of the Female students (as % of total students) in Secondary general education in 1993 to that in 1994?
Keep it short and to the point. 0.99. What is the ratio of the Female students (as % of total students) of Secondary vocational education in 1993 to that in 1994?
Give a very brief answer. 1.02. What is the ratio of the Female students (as % of total students) in Primary education in 1993 to that in 1995?
Provide a short and direct response. 1.01. What is the ratio of the Female students (as % of total students) in Tertiary education in 1993 to that in 1995?
Ensure brevity in your answer.  1.01. What is the ratio of the Female students (as % of total students) of Secondary general education in 1993 to that in 1995?
Make the answer very short. 1.01. What is the ratio of the Female students (as % of total students) in Secondary vocational education in 1993 to that in 1995?
Give a very brief answer. 1.12. What is the ratio of the Female students (as % of total students) in Primary education in 1993 to that in 1996?
Your answer should be compact. 1.01. What is the ratio of the Female students (as % of total students) in Tertiary education in 1993 to that in 1996?
Your answer should be compact. 1.01. What is the ratio of the Female students (as % of total students) of Secondary general education in 1993 to that in 1996?
Ensure brevity in your answer.  1.01. What is the ratio of the Female students (as % of total students) of Secondary vocational education in 1993 to that in 1996?
Offer a very short reply. 1.13. What is the ratio of the Female students (as % of total students) of Tertiary education in 1994 to that in 1995?
Give a very brief answer. 1.01. What is the ratio of the Female students (as % of total students) of Secondary general education in 1994 to that in 1995?
Give a very brief answer. 1.03. What is the ratio of the Female students (as % of total students) in Secondary vocational education in 1994 to that in 1995?
Ensure brevity in your answer.  1.1. What is the ratio of the Female students (as % of total students) of Primary education in 1994 to that in 1996?
Ensure brevity in your answer.  1. What is the ratio of the Female students (as % of total students) in Tertiary education in 1994 to that in 1996?
Provide a succinct answer. 1.01. What is the ratio of the Female students (as % of total students) of Secondary general education in 1994 to that in 1996?
Your response must be concise. 1.03. What is the ratio of the Female students (as % of total students) of Secondary vocational education in 1994 to that in 1996?
Your answer should be very brief. 1.1. What is the ratio of the Female students (as % of total students) in Primary education in 1995 to that in 1996?
Offer a very short reply. 1. What is the ratio of the Female students (as % of total students) in Tertiary education in 1995 to that in 1996?
Your answer should be very brief. 1. What is the ratio of the Female students (as % of total students) in Secondary general education in 1995 to that in 1996?
Give a very brief answer. 1. What is the ratio of the Female students (as % of total students) in Secondary vocational education in 1995 to that in 1996?
Your answer should be very brief. 1. What is the difference between the highest and the second highest Female students (as % of total students) in Primary education?
Your response must be concise. 0.14. What is the difference between the highest and the second highest Female students (as % of total students) in Tertiary education?
Offer a very short reply. 0.19. What is the difference between the highest and the second highest Female students (as % of total students) of Secondary general education?
Give a very brief answer. 0.79. What is the difference between the highest and the second highest Female students (as % of total students) in Secondary vocational education?
Your answer should be very brief. 0.22. What is the difference between the highest and the lowest Female students (as % of total students) of Primary education?
Your answer should be compact. 0.63. What is the difference between the highest and the lowest Female students (as % of total students) of Tertiary education?
Provide a short and direct response. 1.7. What is the difference between the highest and the lowest Female students (as % of total students) in Secondary general education?
Make the answer very short. 1.59. What is the difference between the highest and the lowest Female students (as % of total students) in Secondary vocational education?
Your answer should be compact. 6.7. 